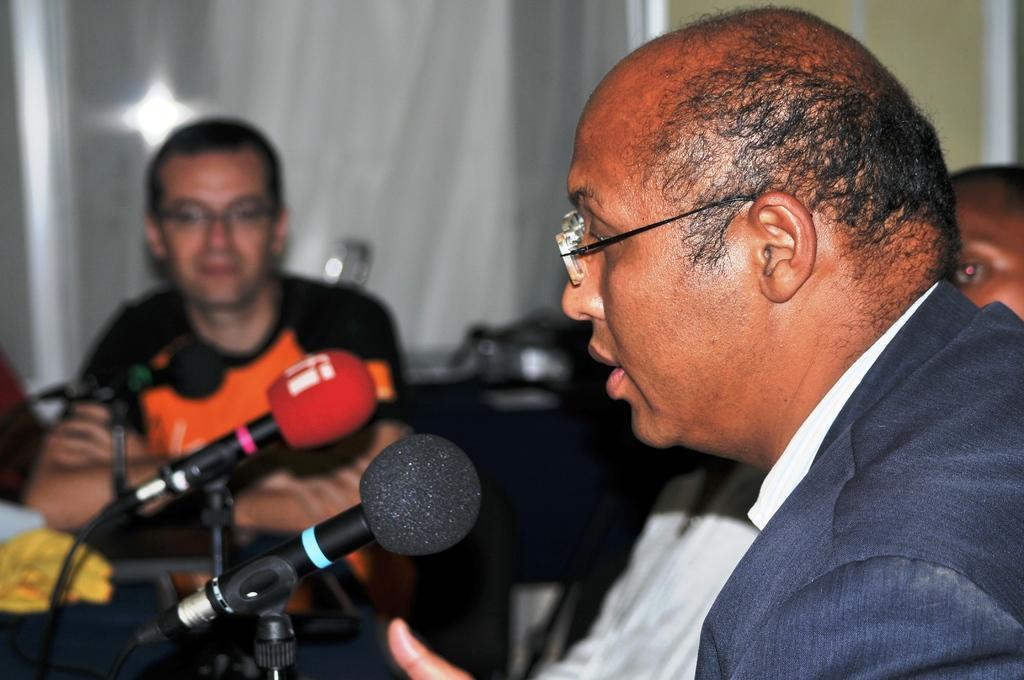Describe this image in one or two sentences. In this image there are group of people sitting, there are miles with the miles stands and some other objects on the table, and in the background there is a wall. 